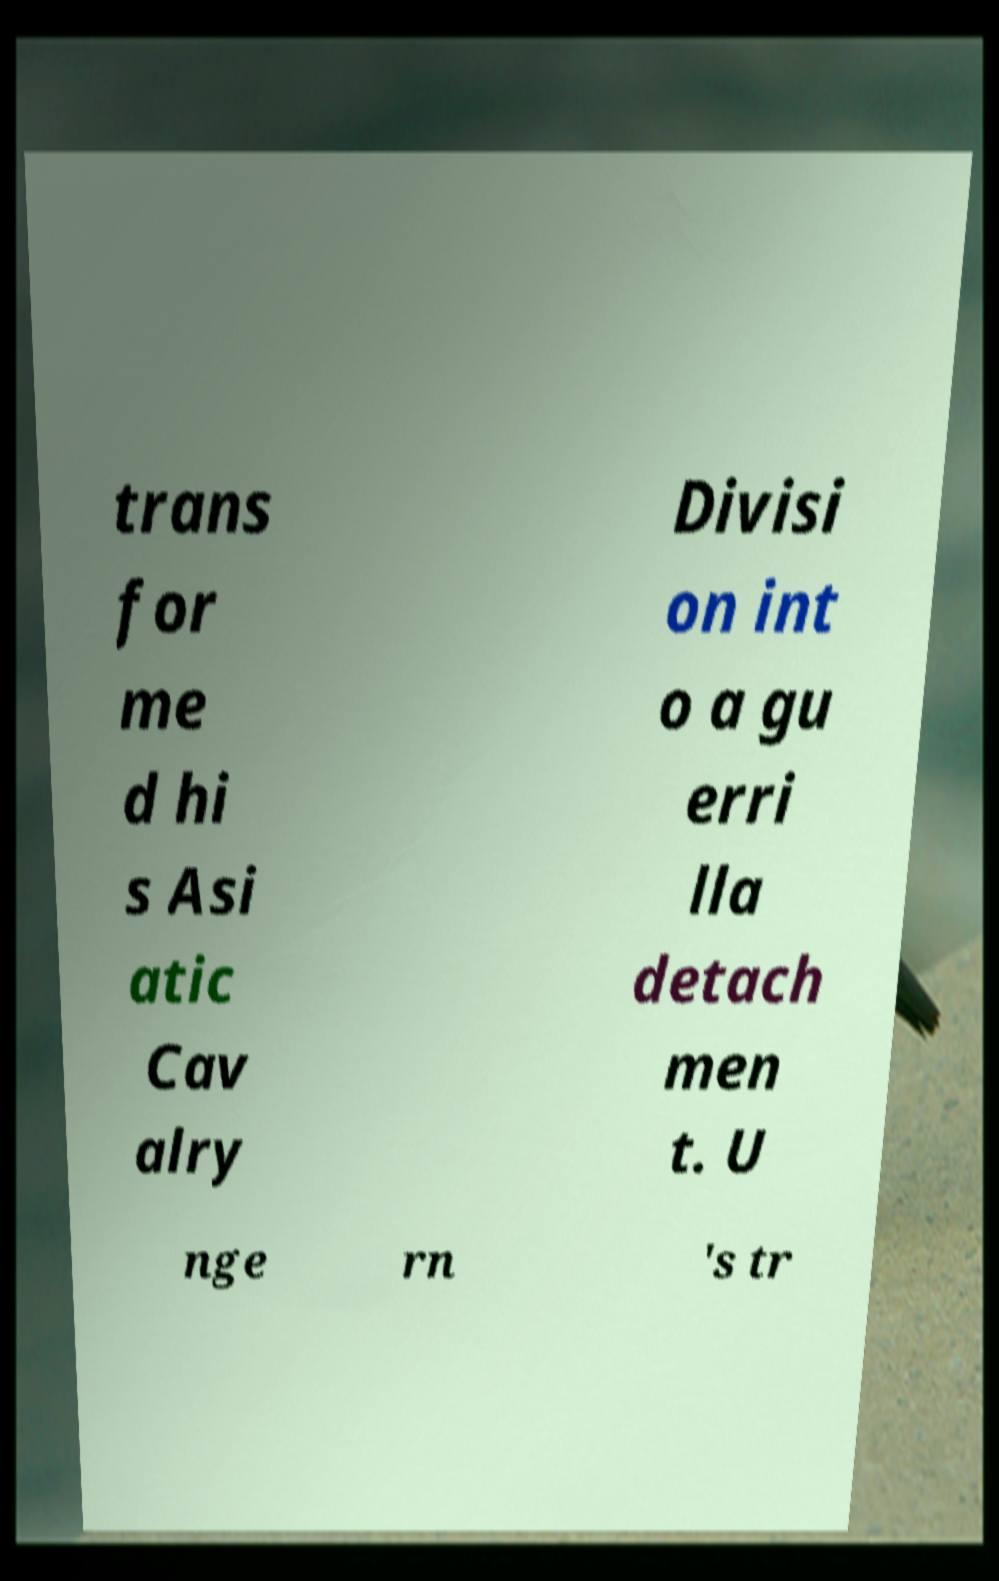Can you read and provide the text displayed in the image?This photo seems to have some interesting text. Can you extract and type it out for me? trans for me d hi s Asi atic Cav alry Divisi on int o a gu erri lla detach men t. U nge rn 's tr 